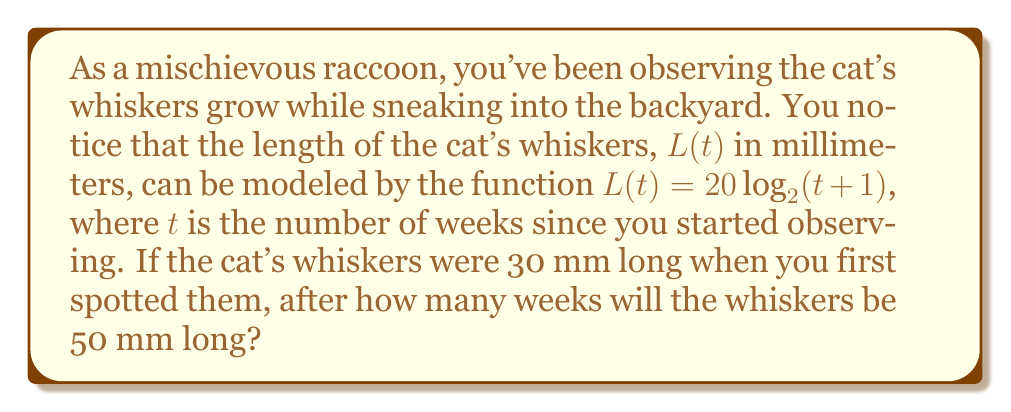What is the answer to this math problem? Let's approach this problem step by step:

1) We're given the function $L(t) = 20 \log_2(t+1)$, where $L(t)$ is the length in mm and $t$ is time in weeks.

2) We need to find $t$ when $L(t) = 50$ mm. So, we can set up the equation:

   $50 = 20 \log_2(t+1)$

3) To solve for $t$, let's first divide both sides by 20:

   $\frac{50}{20} = \log_2(t+1)$
   $2.5 = \log_2(t+1)$

4) Now, we can use the definition of logarithms to rewrite this as an exponential equation:

   $2^{2.5} = t+1$

5) Let's calculate $2^{2.5}$:

   $2^{2.5} \approx 5.6569$

6) So our equation is now:

   $5.6569 = t+1$

7) Subtract 1 from both sides to solve for $t$:

   $t = 5.6569 - 1 = 4.6569$

8) Since time is measured in weeks, we should round this to the nearest week:

   $t \approx 5$ weeks

9) To verify, let's plug this back into our original function:

   $L(5) = 20 \log_2(5+1) = 20 \log_2(6) \approx 51.7$ mm

   This is close to our target of 50 mm, confirming our answer.
Answer: The cat's whiskers will be approximately 50 mm long after 5 weeks. 